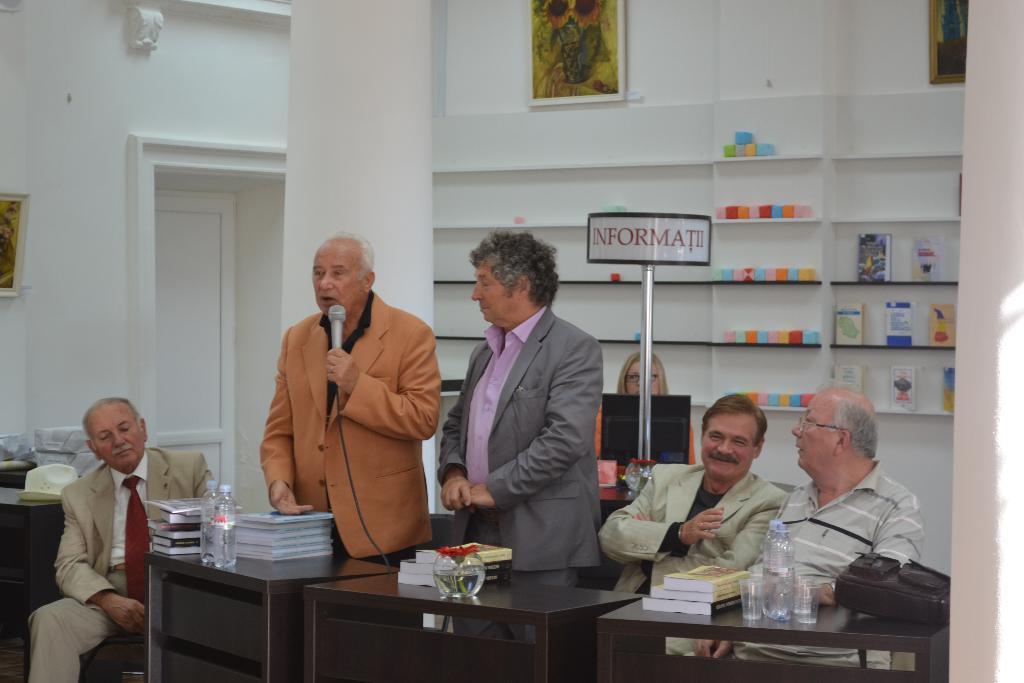Describe this image in one or two sentences. In this picture these two person are standing. These four persons are sitting on the chair. We can see tables. On the table we can see books,bottle,bag,glass,flower. There is a stand. On this background We can see wall,door,frame. He is holding microphone. 